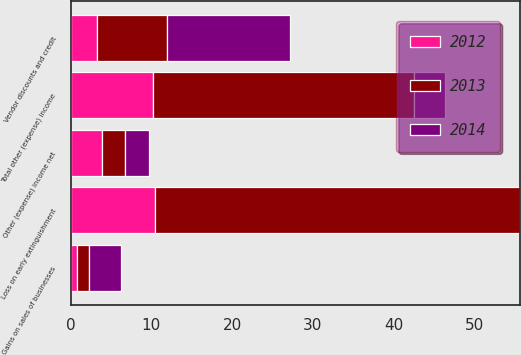Convert chart to OTSL. <chart><loc_0><loc_0><loc_500><loc_500><stacked_bar_chart><ecel><fcel>Loss on early extinguishment<fcel>Gains on sales of businesses<fcel>Vendor discounts and credit<fcel>Other (expense) income net<fcel>Total other (expense) income<nl><fcel>2012<fcel>10.4<fcel>0.8<fcel>3.3<fcel>3.9<fcel>10.2<nl><fcel>2013<fcel>45.2<fcel>1.5<fcel>8.6<fcel>2.8<fcel>32.3<nl><fcel>2014<fcel>0<fcel>3.9<fcel>15.3<fcel>3<fcel>3.9<nl></chart> 